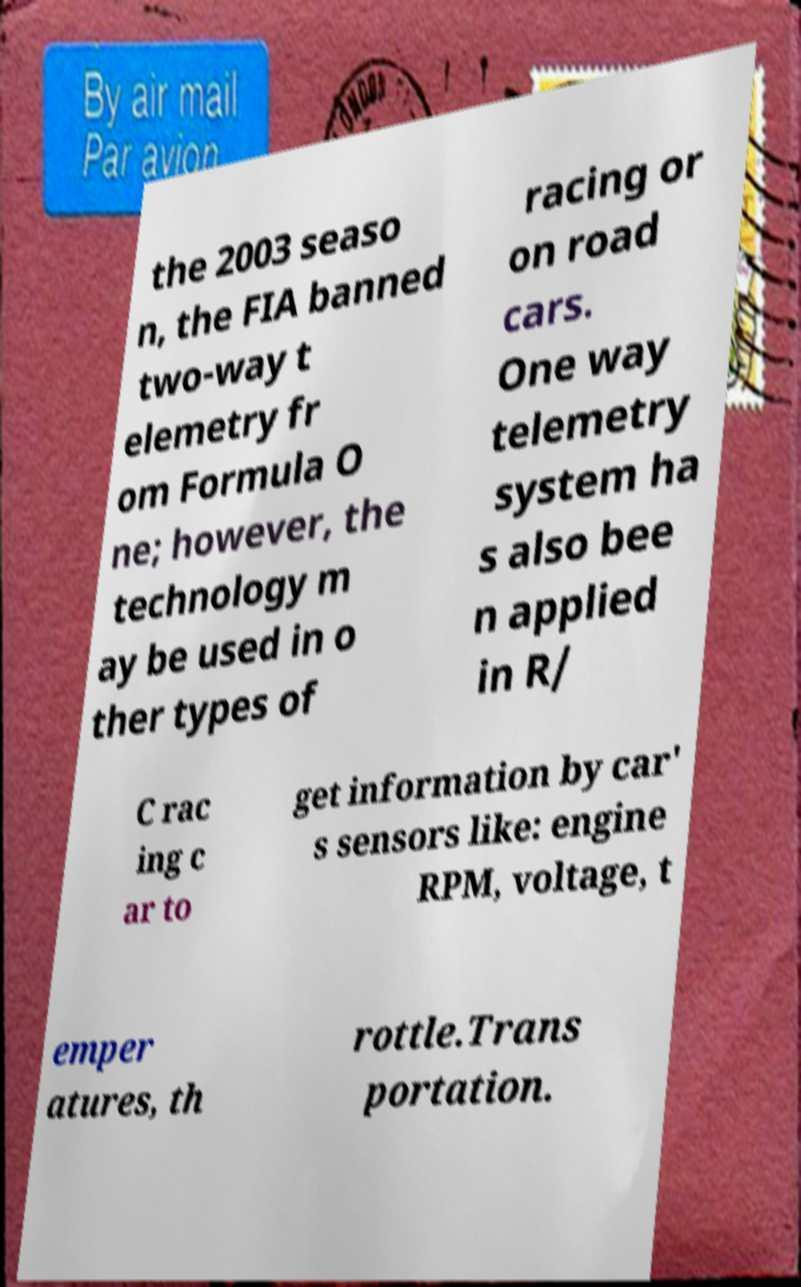What messages or text are displayed in this image? I need them in a readable, typed format. the 2003 seaso n, the FIA banned two-way t elemetry fr om Formula O ne; however, the technology m ay be used in o ther types of racing or on road cars. One way telemetry system ha s also bee n applied in R/ C rac ing c ar to get information by car' s sensors like: engine RPM, voltage, t emper atures, th rottle.Trans portation. 